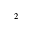<formula> <loc_0><loc_0><loc_500><loc_500>^ { 2 }</formula> 